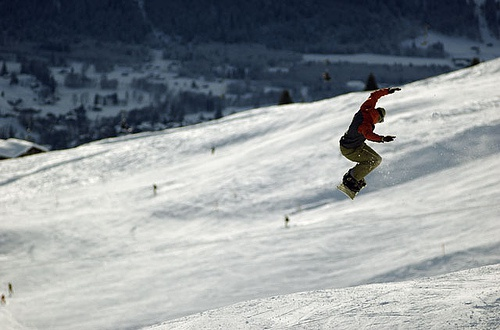Describe the objects in this image and their specific colors. I can see people in black, maroon, lightgray, and darkgray tones, snowboard in black, gray, darkgreen, and darkgray tones, people in black, darkgray, gray, and darkgreen tones, and people in black, gray, olive, and darkgreen tones in this image. 